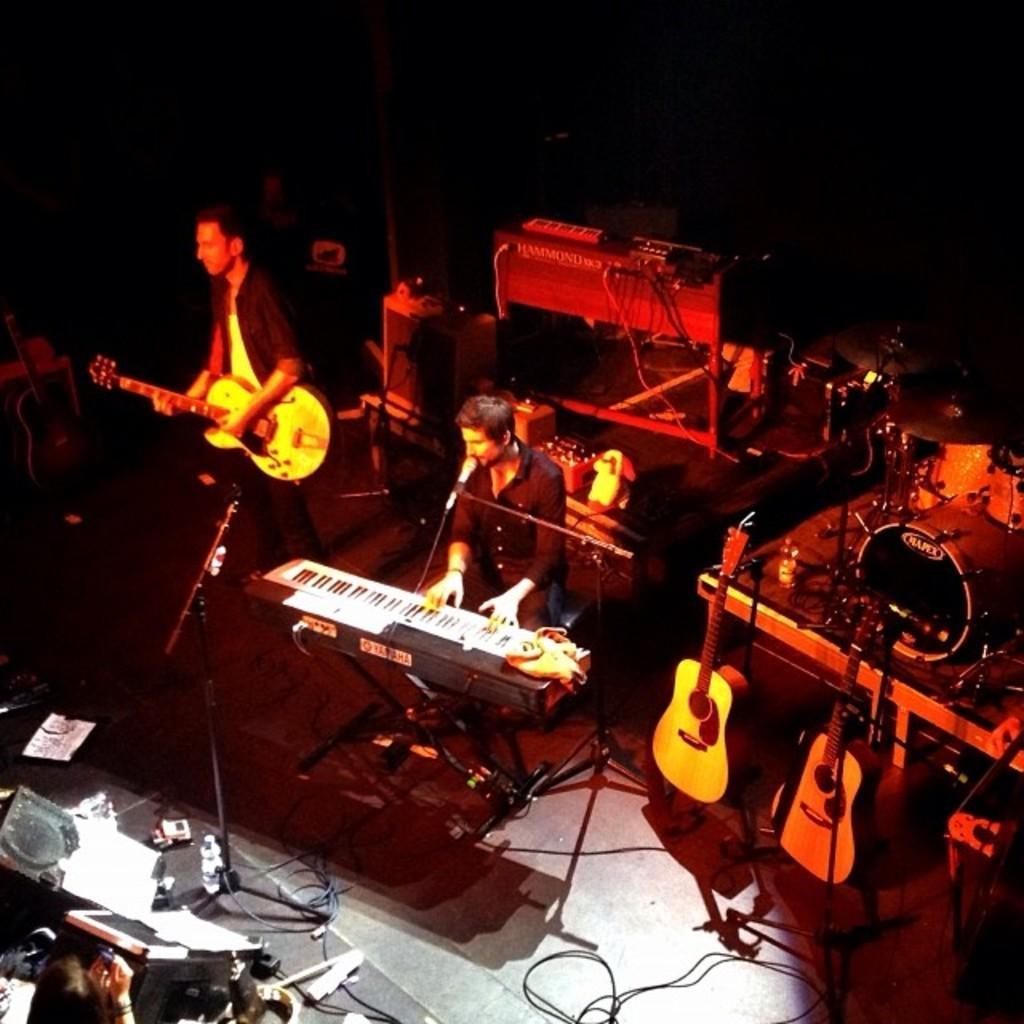Describe this image in one or two sentences. The two persons are standing. They are playing musical instruments. 